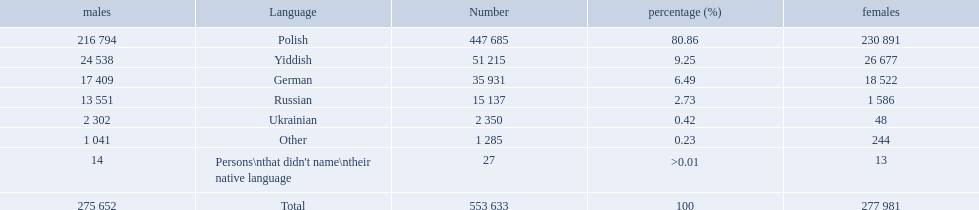What are all of the languages? Polish, Yiddish, German, Russian, Ukrainian, Other, Persons\nthat didn't name\ntheir native language. And how many people speak these languages? 447 685, 51 215, 35 931, 15 137, 2 350, 1 285, 27. Which language is used by most people? Polish. 